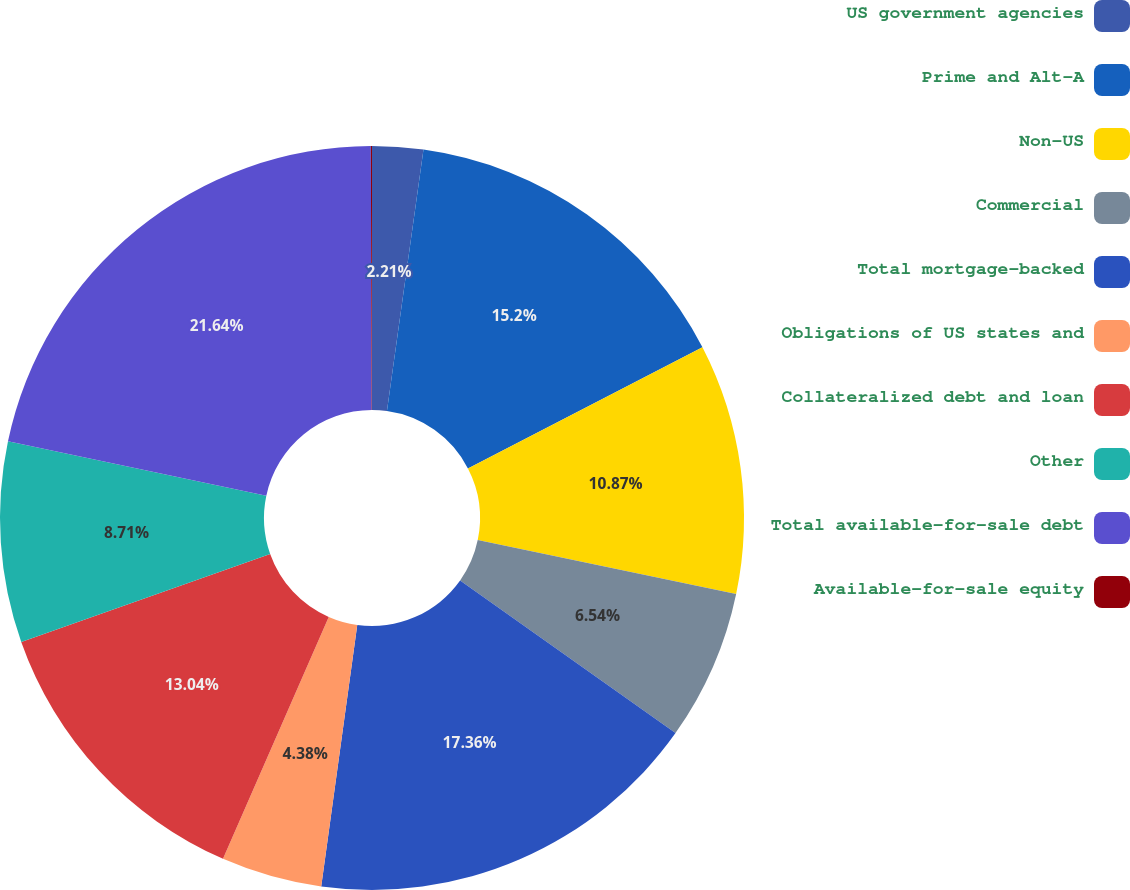Convert chart to OTSL. <chart><loc_0><loc_0><loc_500><loc_500><pie_chart><fcel>US government agencies<fcel>Prime and Alt-A<fcel>Non-US<fcel>Commercial<fcel>Total mortgage-backed<fcel>Obligations of US states and<fcel>Collateralized debt and loan<fcel>Other<fcel>Total available-for-sale debt<fcel>Available-for-sale equity<nl><fcel>2.21%<fcel>15.2%<fcel>10.87%<fcel>6.54%<fcel>17.37%<fcel>4.38%<fcel>13.04%<fcel>8.71%<fcel>21.65%<fcel>0.05%<nl></chart> 